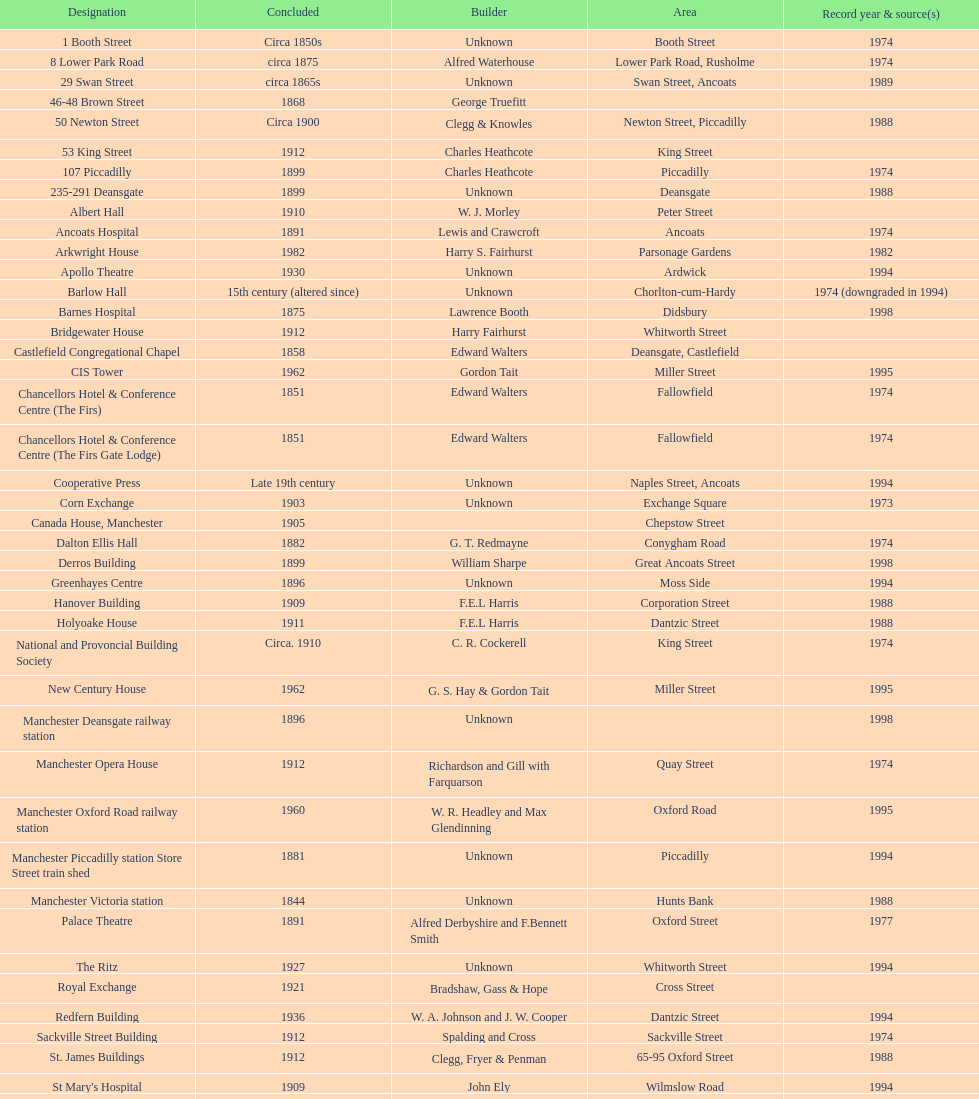How many names are listed with an image? 39. 